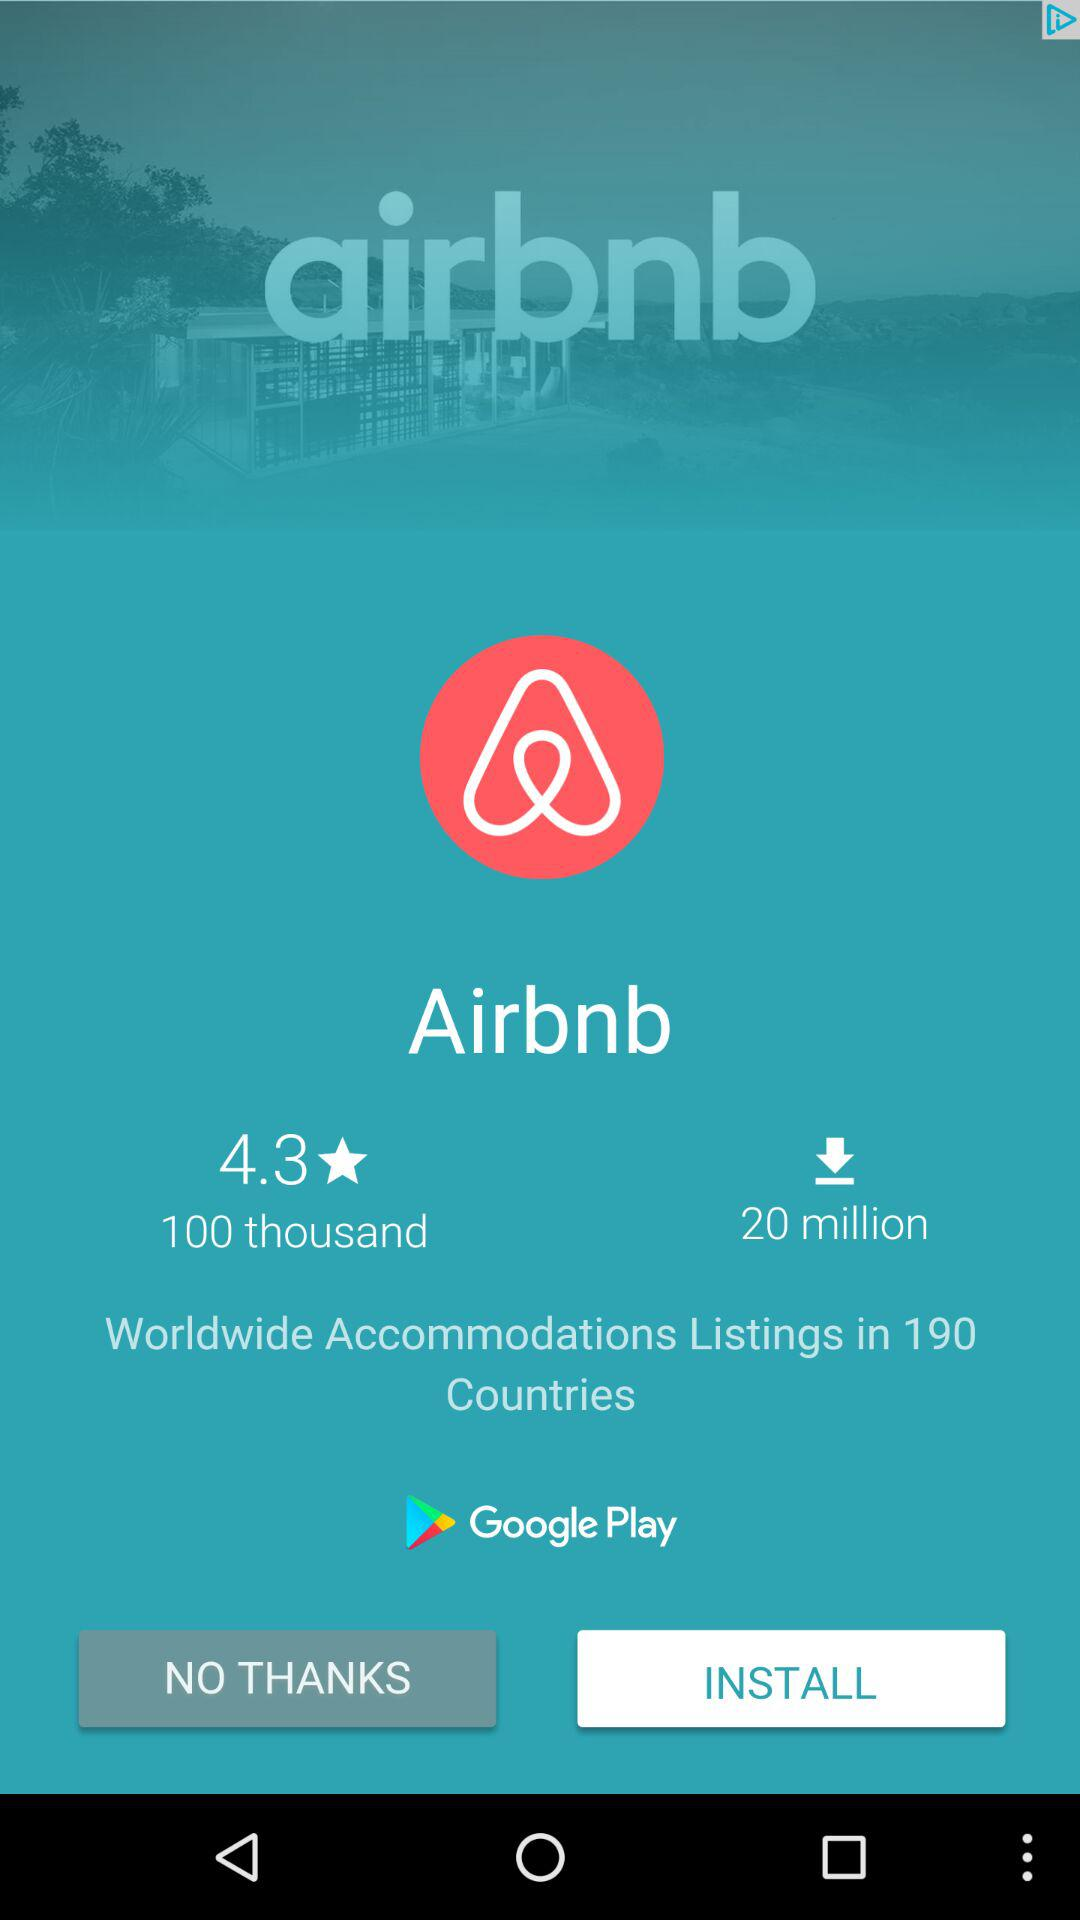How many reviews are there for Airbnb?
Answer the question using a single word or phrase. 100 thousand 